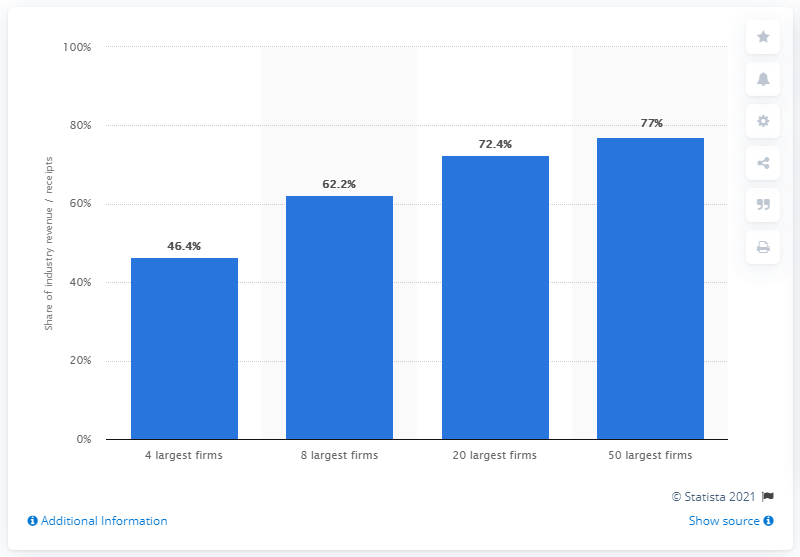Identify some key points in this picture. In 2012, the eight largest firms in the industry accounted for 62.2% of the industry's total revenue. 